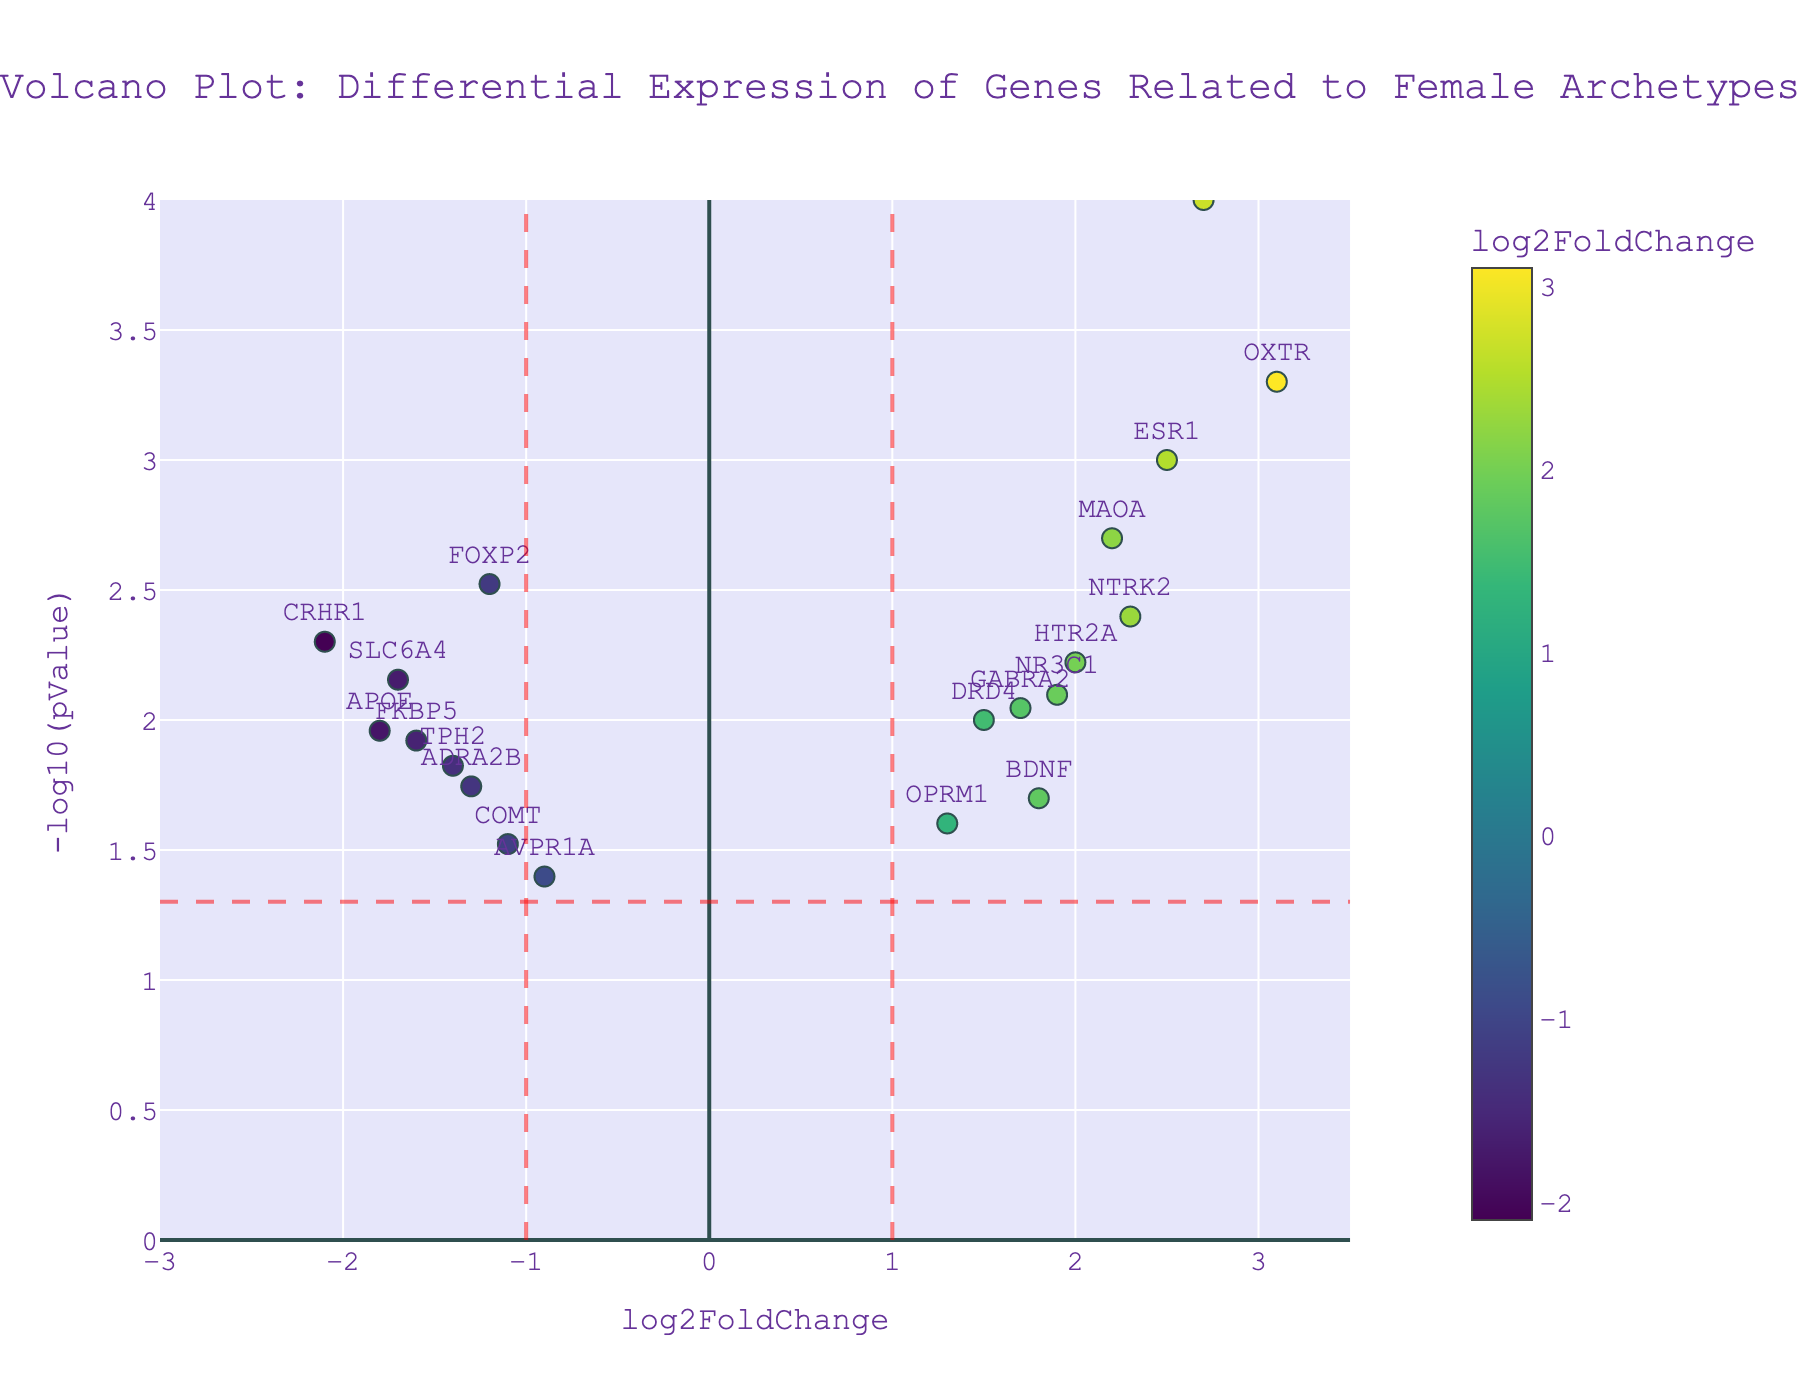What is the title of the volcano plot? The title of the plot is displayed at the top center of the figure.
Answer: Volcano Plot: Differential Expression of Genes Related to Female Archetypes How many genes show a positive log2FoldChange greater than 2? By looking at the horizontal axis, we can count the number of points positioned to the right of the value 2 on the x-axis.
Answer: 5 Which gene has the smallest p-value? The smallest p-value corresponds to the highest -log10(pValue) on the y-axis.
Answer: CACNA1C How many genes have a negative log2FoldChange and a p-value less than 0.05? Look for points with x-values less than 0 and y-values above the horizontal red line at -log10(pValue) = 1.301. Count these points.
Answer: 6 Is the gene ESR1 more highly upregulated or downregulated, and by how much? ESR1's log2FoldChange is 2.5, which indicates upregulation.
Answer: Upregulated by 2.5 What is the log2FoldChange value for the gene with the highest -log10(pValue)? The gene with the highest -log10(pValue) is identified first; its log2FoldChange value is then read from the x-axis. The gene CACNA1C has the highest -log10(pValue).
Answer: 2.7 Are there more upregulated or downregulated genes with significant p-values (p < 0.05)? Count the points on both sides of the vertical dashed lines. Check if the points are above the horizontal dashed line (significance). Compare these counts.
Answer: More upregulated genes Which genes are close to the significance threshold, with p-values just around 0.05? Look for points near the horizontal dashed line at -log10(pValue) = 1.301. Identify the genes that are near this line on both sides of the plot.
Answer: AVPR1A and OPRM1 What’s the average log2FoldChange of the downregulated genes? Add the log2FoldChange values of genes with negative values and divide by the number of such genes. (-1.2 - 0.9 - 1.7 - 1.1 - 1.4 - 2.1 - 1.6 - 1.3 - 1.8) / 9 = -13.1 / 9 = -1.46
Answer: -1.46 